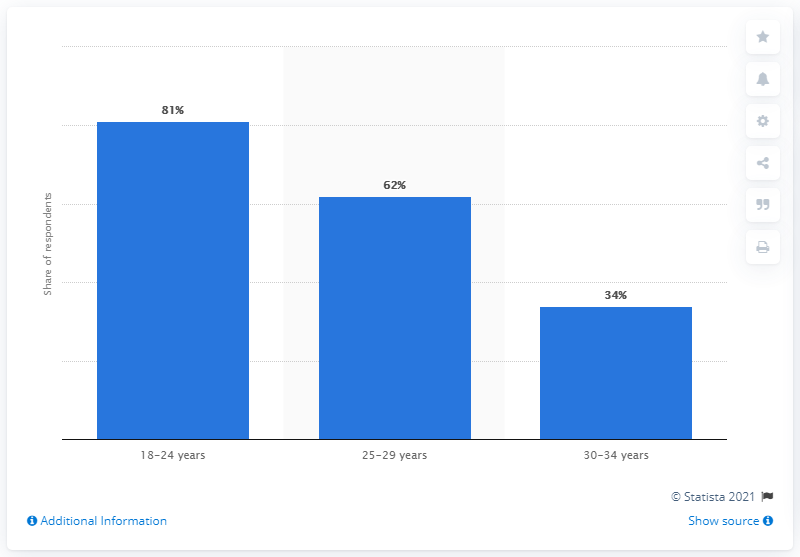Draw attention to some important aspects in this diagram. According to data, approximately 34% of Italians aged 30 to 34 resided with their parents in 2021. According to a recent survey, 81% of 18-24 year olds in the United States live with their parents. 